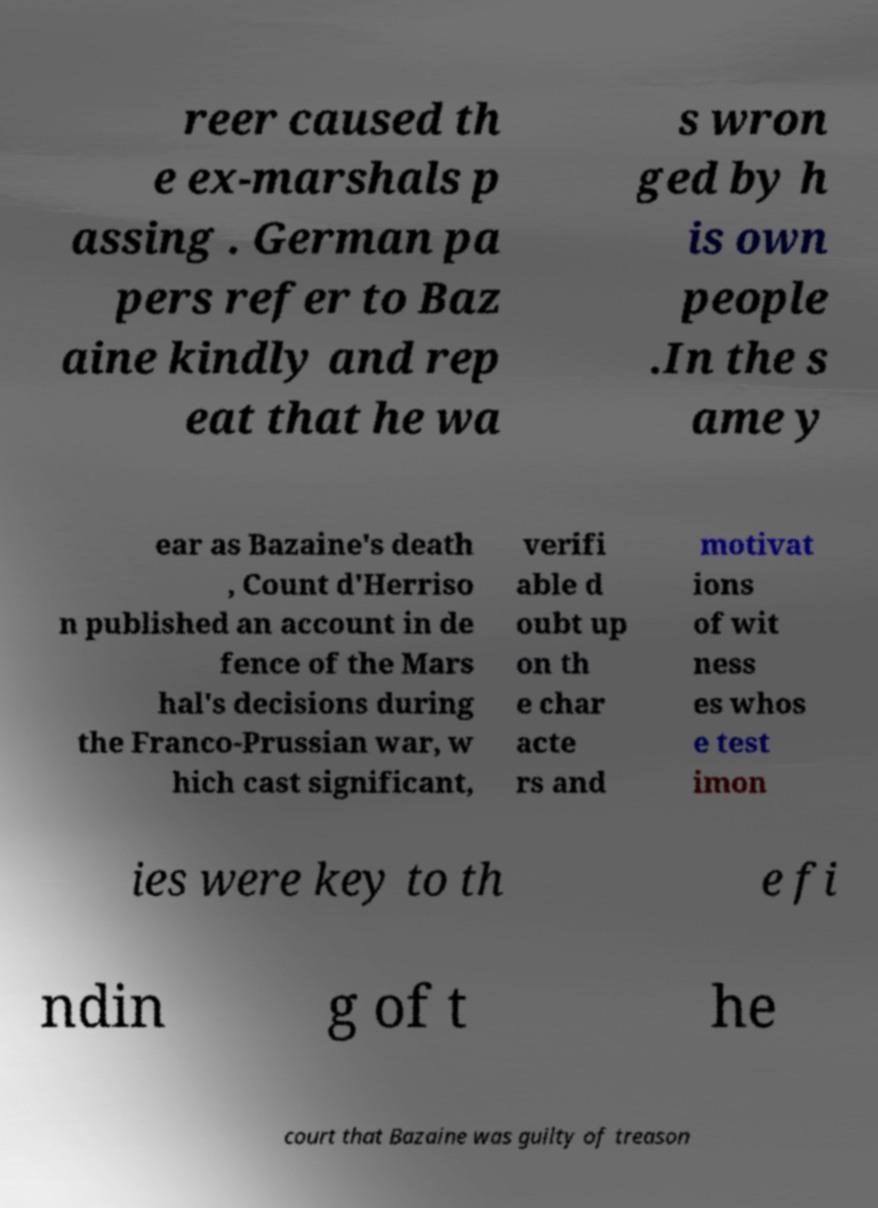For documentation purposes, I need the text within this image transcribed. Could you provide that? reer caused th e ex-marshals p assing . German pa pers refer to Baz aine kindly and rep eat that he wa s wron ged by h is own people .In the s ame y ear as Bazaine's death , Count d'Herriso n published an account in de fence of the Mars hal's decisions during the Franco-Prussian war, w hich cast significant, verifi able d oubt up on th e char acte rs and motivat ions of wit ness es whos e test imon ies were key to th e fi ndin g of t he court that Bazaine was guilty of treason 